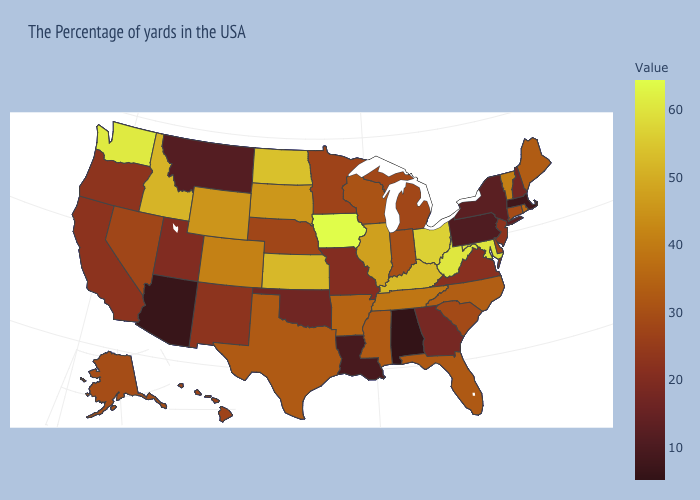Among the states that border Nebraska , which have the lowest value?
Write a very short answer. Missouri. Which states hav the highest value in the West?
Be succinct. Washington. Does Kentucky have the highest value in the USA?
Be succinct. No. Does the map have missing data?
Answer briefly. No. Among the states that border New Hampshire , which have the highest value?
Answer briefly. Vermont. Among the states that border Alabama , does Tennessee have the highest value?
Concise answer only. Yes. Does Iowa have the highest value in the USA?
Short answer required. Yes. 